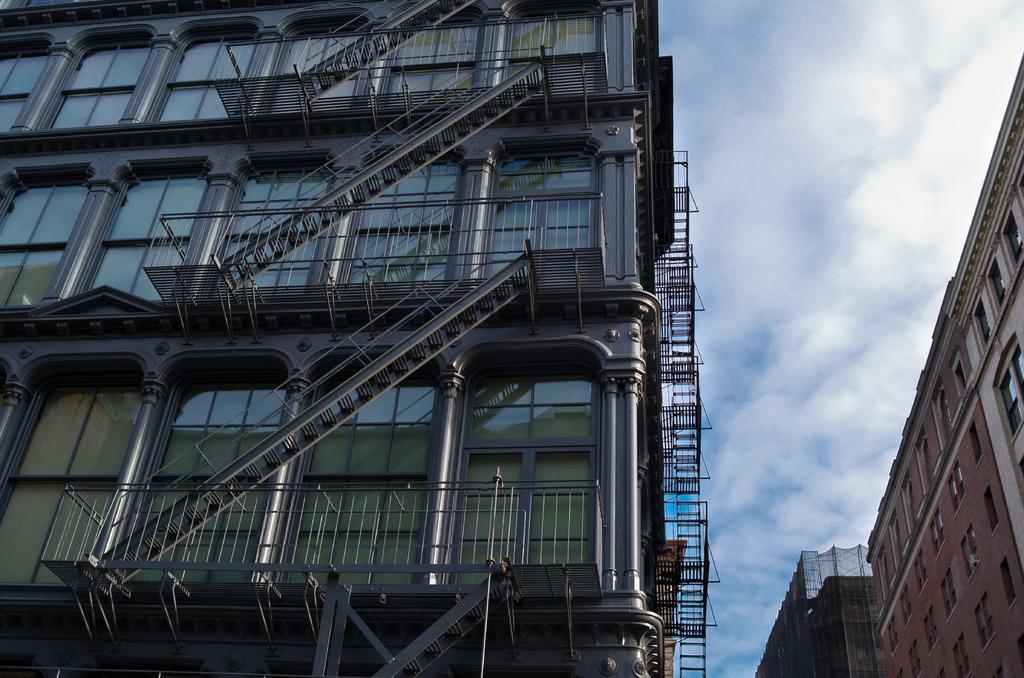Could you give a brief overview of what you see in this image? In this image, we can see a glass building with pillars, railings and stairs. Right side of the image, we can see buildings, wall, glass windows. Here we can see the sky. 